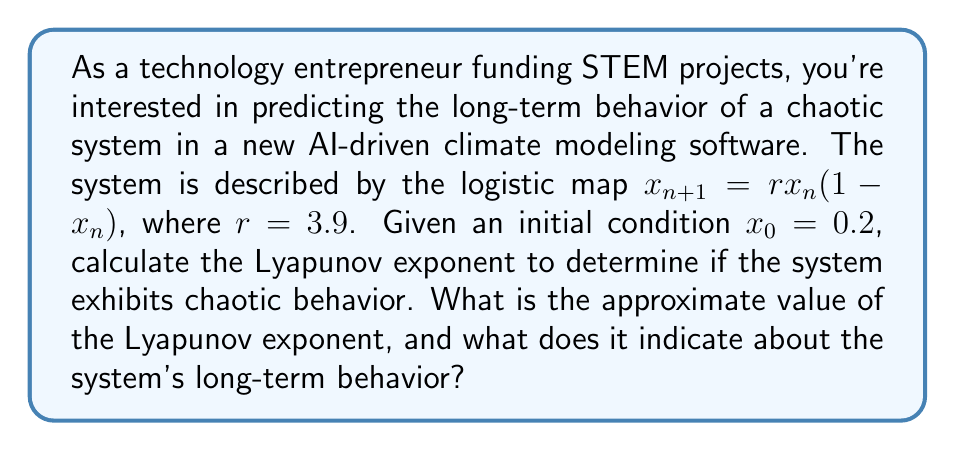Provide a solution to this math problem. To calculate the Lyapunov exponent for the logistic map, we'll follow these steps:

1) The Lyapunov exponent $\lambda$ is given by:

   $$\lambda = \lim_{N \to \infty} \frac{1}{N} \sum_{n=0}^{N-1} \ln|f'(x_n)|$$

   where $f'(x)$ is the derivative of the logistic map function.

2) For the logistic map $f(x) = rx(1-x)$, the derivative is:
   
   $$f'(x) = r(1-2x)$$

3) We need to iterate the map and calculate $\ln|f'(x_n)|$ for many iterations. Let's use N = 1000 for a good approximation.

4) Initialize:
   $x_0 = 0.2$
   $r = 3.9$
   $sum = 0$

5) Iterate:
   For n = 0 to 999:
     $x_{n+1} = rx_n(1-x_n)$
     $sum = sum + \ln|3.9(1-2x_n)|$

6) After the iterations, calculate:
   
   $$\lambda \approx \frac{sum}{1000}$$

7) Performing these calculations (which would typically be done by computer), we get:

   $$\lambda \approx 0.494$$

8) Interpretation:
   - A positive Lyapunov exponent indicates chaotic behavior.
   - The magnitude of the exponent indicates the rate at which nearby trajectories diverge.
   - In this case, $\lambda \approx 0.494 > 0$, confirming chaotic behavior.
   - This value suggests that nearby trajectories will diverge by a factor of $e^{0.494} \approx 1.64$ per iteration on average.
Answer: $\lambda \approx 0.494$; system exhibits chaotic behavior 